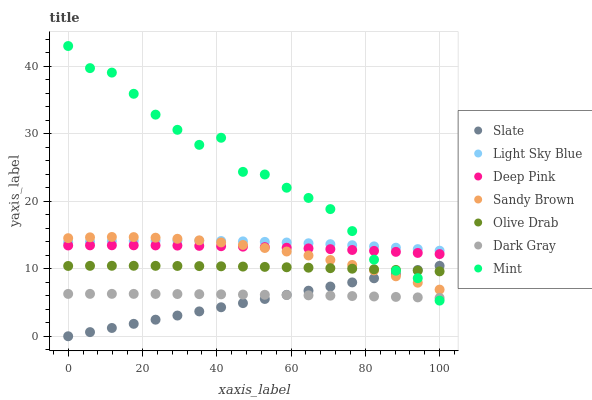Does Slate have the minimum area under the curve?
Answer yes or no. Yes. Does Mint have the maximum area under the curve?
Answer yes or no. Yes. Does Mint have the minimum area under the curve?
Answer yes or no. No. Does Slate have the maximum area under the curve?
Answer yes or no. No. Is Slate the smoothest?
Answer yes or no. Yes. Is Mint the roughest?
Answer yes or no. Yes. Is Mint the smoothest?
Answer yes or no. No. Is Slate the roughest?
Answer yes or no. No. Does Slate have the lowest value?
Answer yes or no. Yes. Does Mint have the lowest value?
Answer yes or no. No. Does Mint have the highest value?
Answer yes or no. Yes. Does Slate have the highest value?
Answer yes or no. No. Is Olive Drab less than Deep Pink?
Answer yes or no. Yes. Is Light Sky Blue greater than Slate?
Answer yes or no. Yes. Does Sandy Brown intersect Deep Pink?
Answer yes or no. Yes. Is Sandy Brown less than Deep Pink?
Answer yes or no. No. Is Sandy Brown greater than Deep Pink?
Answer yes or no. No. Does Olive Drab intersect Deep Pink?
Answer yes or no. No. 